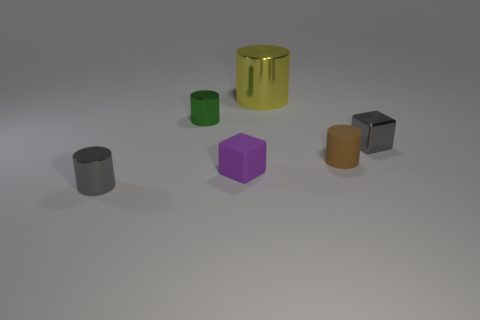Are there any small blue cubes?
Ensure brevity in your answer.  No. How many objects are small objects that are in front of the purple cube or blocks?
Provide a succinct answer. 3. Do the small shiny cube and the thing in front of the purple rubber block have the same color?
Provide a short and direct response. Yes. Is there a brown metal sphere of the same size as the green metallic cylinder?
Make the answer very short. No. There is a cylinder in front of the rubber object to the right of the big shiny cylinder; what is it made of?
Offer a terse response. Metal. How many cylinders have the same color as the metallic block?
Provide a short and direct response. 1. There is a large yellow thing that is made of the same material as the small green cylinder; what shape is it?
Offer a terse response. Cylinder. What is the size of the metal cylinder that is on the right side of the small matte cube?
Provide a short and direct response. Large. Is the number of small shiny cylinders that are behind the large cylinder the same as the number of tiny brown things that are to the left of the small shiny cube?
Offer a very short reply. No. There is a small metal cylinder behind the cylinder in front of the small cube to the left of the small shiny cube; what color is it?
Your answer should be very brief. Green. 